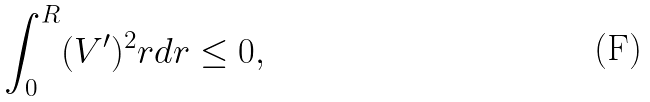<formula> <loc_0><loc_0><loc_500><loc_500>\int _ { 0 } ^ { R } ( V ^ { \prime } ) ^ { 2 } r d r \leq 0 ,</formula> 